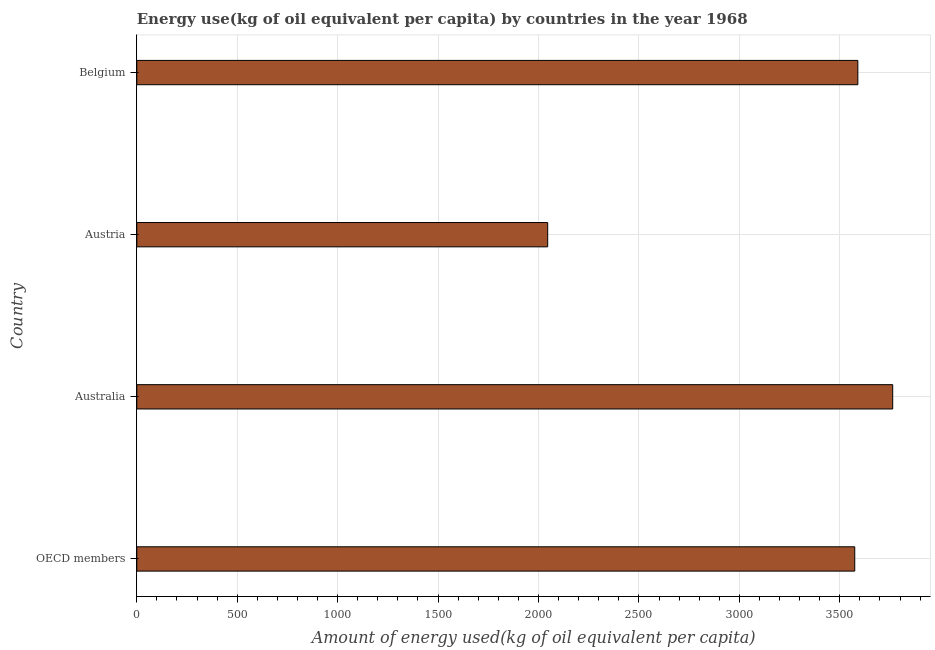Does the graph contain grids?
Ensure brevity in your answer.  Yes. What is the title of the graph?
Ensure brevity in your answer.  Energy use(kg of oil equivalent per capita) by countries in the year 1968. What is the label or title of the X-axis?
Provide a short and direct response. Amount of energy used(kg of oil equivalent per capita). What is the label or title of the Y-axis?
Offer a terse response. Country. What is the amount of energy used in Australia?
Your answer should be very brief. 3763.56. Across all countries, what is the maximum amount of energy used?
Offer a terse response. 3763.56. Across all countries, what is the minimum amount of energy used?
Give a very brief answer. 2045.83. What is the sum of the amount of energy used?
Provide a succinct answer. 1.30e+04. What is the difference between the amount of energy used in Austria and Belgium?
Make the answer very short. -1544.18. What is the average amount of energy used per country?
Your answer should be very brief. 3243.51. What is the median amount of energy used?
Provide a succinct answer. 3582.33. What is the ratio of the amount of energy used in Australia to that in Belgium?
Make the answer very short. 1.05. Is the amount of energy used in Australia less than that in Belgium?
Your answer should be very brief. No. What is the difference between the highest and the second highest amount of energy used?
Your answer should be compact. 173.55. Is the sum of the amount of energy used in Australia and Austria greater than the maximum amount of energy used across all countries?
Offer a very short reply. Yes. What is the difference between the highest and the lowest amount of energy used?
Keep it short and to the point. 1717.73. Are all the bars in the graph horizontal?
Provide a succinct answer. Yes. What is the Amount of energy used(kg of oil equivalent per capita) of OECD members?
Make the answer very short. 3574.65. What is the Amount of energy used(kg of oil equivalent per capita) of Australia?
Offer a terse response. 3763.56. What is the Amount of energy used(kg of oil equivalent per capita) in Austria?
Ensure brevity in your answer.  2045.83. What is the Amount of energy used(kg of oil equivalent per capita) of Belgium?
Your answer should be very brief. 3590. What is the difference between the Amount of energy used(kg of oil equivalent per capita) in OECD members and Australia?
Provide a short and direct response. -188.91. What is the difference between the Amount of energy used(kg of oil equivalent per capita) in OECD members and Austria?
Make the answer very short. 1528.82. What is the difference between the Amount of energy used(kg of oil equivalent per capita) in OECD members and Belgium?
Your response must be concise. -15.36. What is the difference between the Amount of energy used(kg of oil equivalent per capita) in Australia and Austria?
Keep it short and to the point. 1717.73. What is the difference between the Amount of energy used(kg of oil equivalent per capita) in Australia and Belgium?
Offer a terse response. 173.55. What is the difference between the Amount of energy used(kg of oil equivalent per capita) in Austria and Belgium?
Your response must be concise. -1544.18. What is the ratio of the Amount of energy used(kg of oil equivalent per capita) in OECD members to that in Australia?
Offer a very short reply. 0.95. What is the ratio of the Amount of energy used(kg of oil equivalent per capita) in OECD members to that in Austria?
Make the answer very short. 1.75. What is the ratio of the Amount of energy used(kg of oil equivalent per capita) in OECD members to that in Belgium?
Make the answer very short. 1. What is the ratio of the Amount of energy used(kg of oil equivalent per capita) in Australia to that in Austria?
Your response must be concise. 1.84. What is the ratio of the Amount of energy used(kg of oil equivalent per capita) in Australia to that in Belgium?
Offer a very short reply. 1.05. What is the ratio of the Amount of energy used(kg of oil equivalent per capita) in Austria to that in Belgium?
Keep it short and to the point. 0.57. 